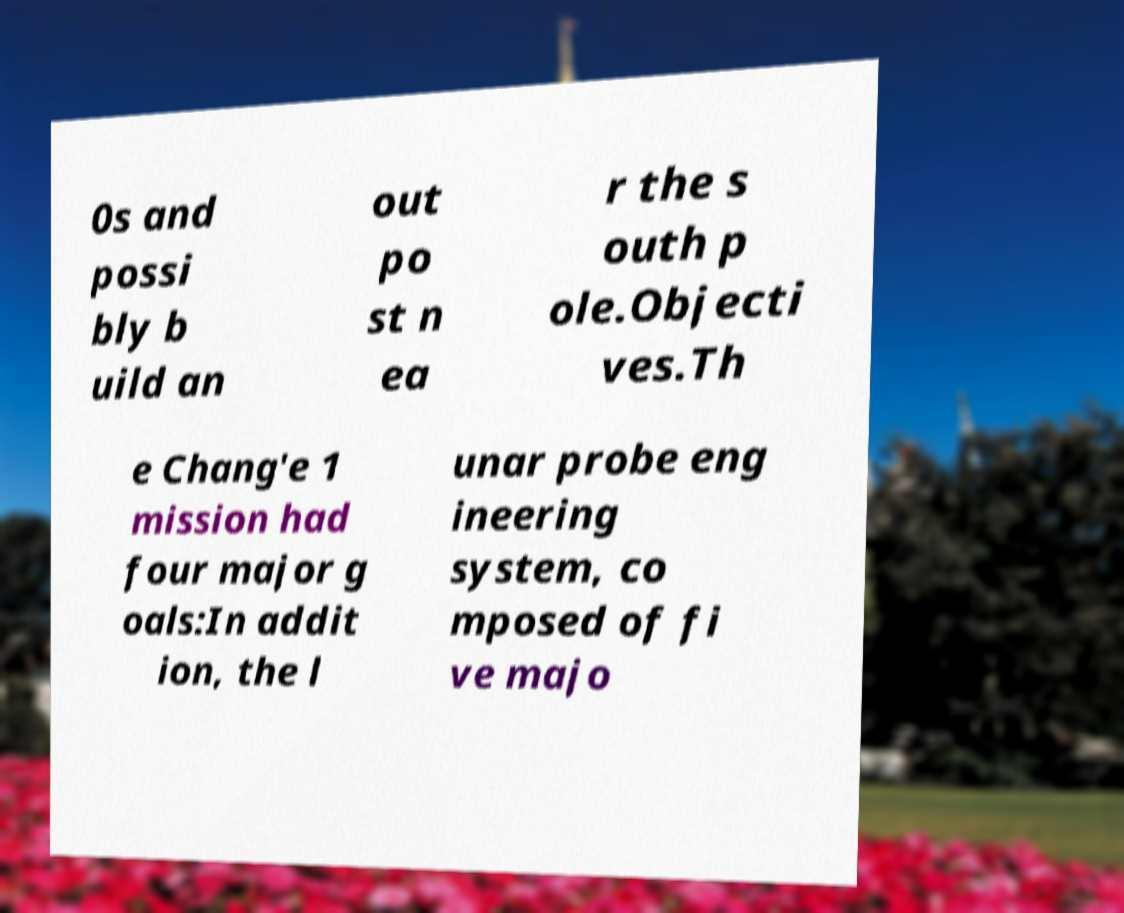Can you accurately transcribe the text from the provided image for me? 0s and possi bly b uild an out po st n ea r the s outh p ole.Objecti ves.Th e Chang'e 1 mission had four major g oals:In addit ion, the l unar probe eng ineering system, co mposed of fi ve majo 